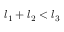Convert formula to latex. <formula><loc_0><loc_0><loc_500><loc_500>l _ { 1 } + l _ { 2 } < l _ { 3 }</formula> 